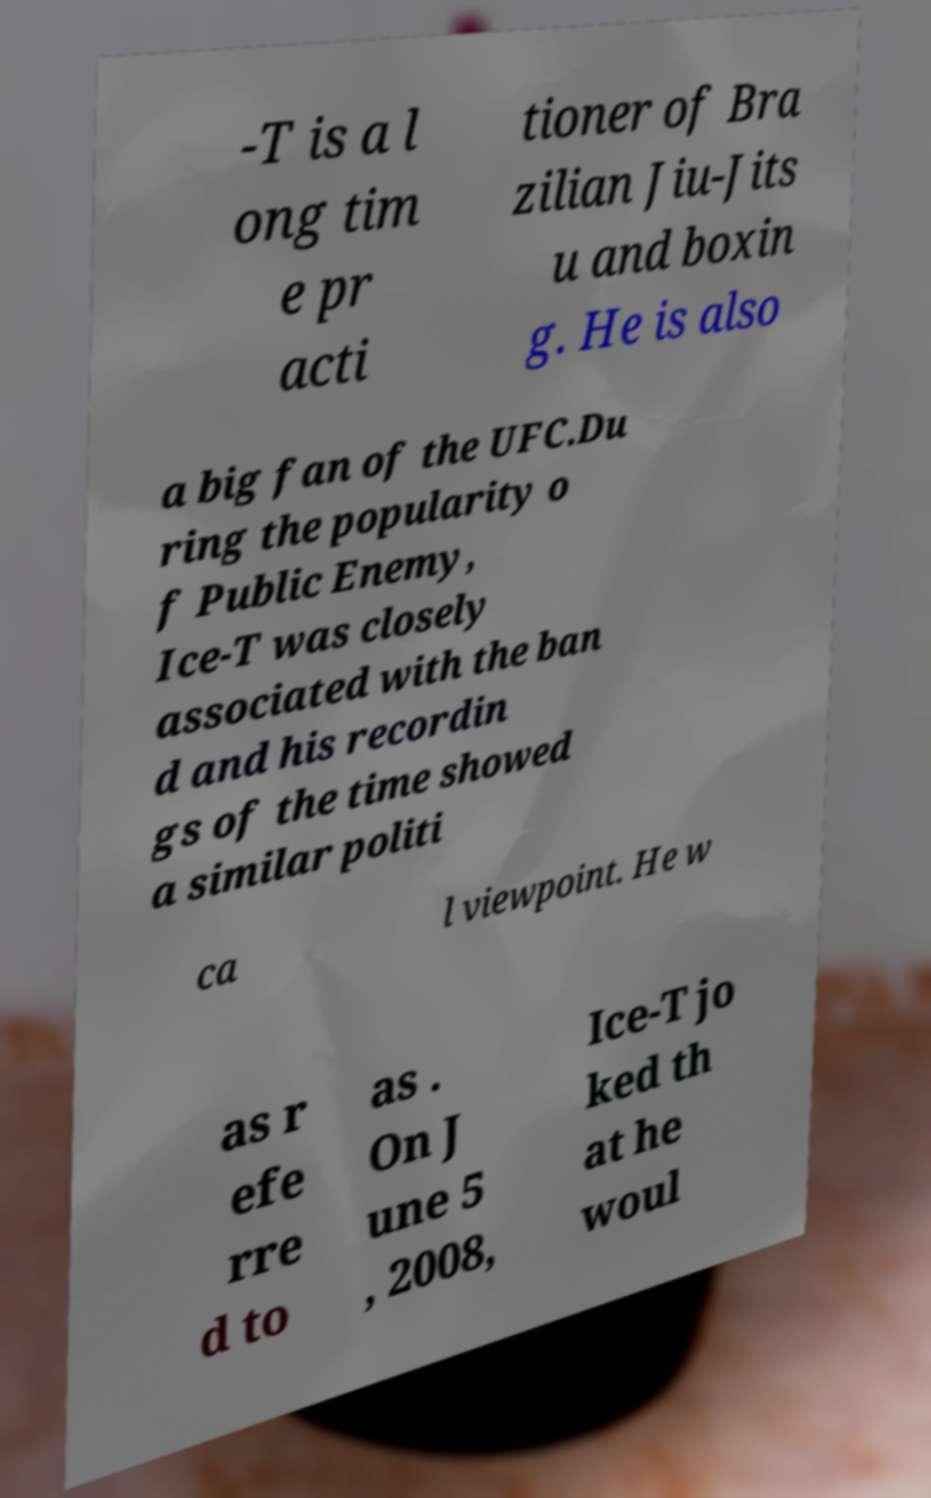Can you accurately transcribe the text from the provided image for me? -T is a l ong tim e pr acti tioner of Bra zilian Jiu-Jits u and boxin g. He is also a big fan of the UFC.Du ring the popularity o f Public Enemy, Ice-T was closely associated with the ban d and his recordin gs of the time showed a similar politi ca l viewpoint. He w as r efe rre d to as . On J une 5 , 2008, Ice-T jo ked th at he woul 